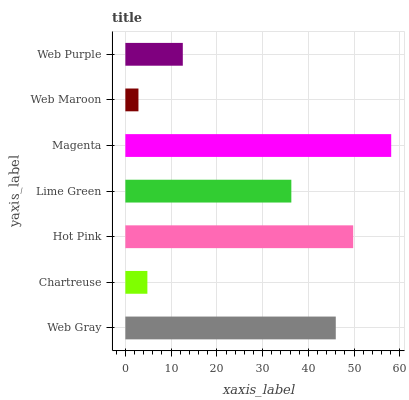Is Web Maroon the minimum?
Answer yes or no. Yes. Is Magenta the maximum?
Answer yes or no. Yes. Is Chartreuse the minimum?
Answer yes or no. No. Is Chartreuse the maximum?
Answer yes or no. No. Is Web Gray greater than Chartreuse?
Answer yes or no. Yes. Is Chartreuse less than Web Gray?
Answer yes or no. Yes. Is Chartreuse greater than Web Gray?
Answer yes or no. No. Is Web Gray less than Chartreuse?
Answer yes or no. No. Is Lime Green the high median?
Answer yes or no. Yes. Is Lime Green the low median?
Answer yes or no. Yes. Is Web Gray the high median?
Answer yes or no. No. Is Web Maroon the low median?
Answer yes or no. No. 